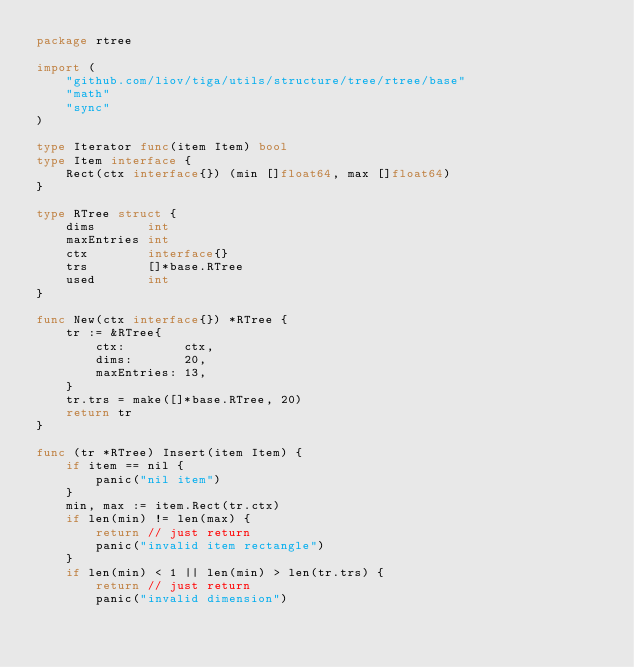<code> <loc_0><loc_0><loc_500><loc_500><_Go_>package rtree

import (
	"github.com/liov/tiga/utils/structure/tree/rtree/base"
	"math"
	"sync"
)

type Iterator func(item Item) bool
type Item interface {
	Rect(ctx interface{}) (min []float64, max []float64)
}

type RTree struct {
	dims       int
	maxEntries int
	ctx        interface{}
	trs        []*base.RTree
	used       int
}

func New(ctx interface{}) *RTree {
	tr := &RTree{
		ctx:        ctx,
		dims:       20,
		maxEntries: 13,
	}
	tr.trs = make([]*base.RTree, 20)
	return tr
}

func (tr *RTree) Insert(item Item) {
	if item == nil {
		panic("nil item")
	}
	min, max := item.Rect(tr.ctx)
	if len(min) != len(max) {
		return // just return
		panic("invalid item rectangle")
	}
	if len(min) < 1 || len(min) > len(tr.trs) {
		return // just return
		panic("invalid dimension")</code> 